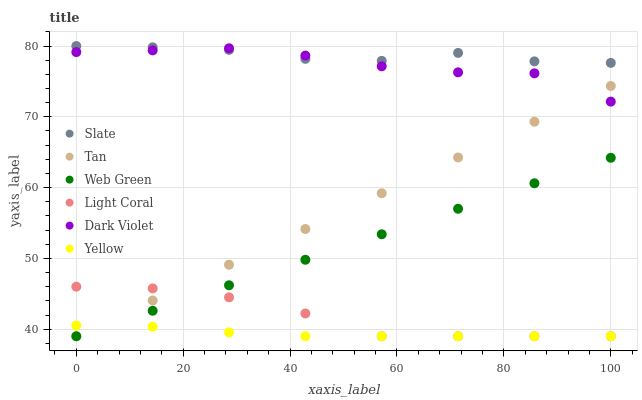Does Yellow have the minimum area under the curve?
Answer yes or no. Yes. Does Slate have the maximum area under the curve?
Answer yes or no. Yes. Does Slate have the minimum area under the curve?
Answer yes or no. No. Does Yellow have the maximum area under the curve?
Answer yes or no. No. Is Web Green the smoothest?
Answer yes or no. Yes. Is Dark Violet the roughest?
Answer yes or no. Yes. Is Slate the smoothest?
Answer yes or no. No. Is Slate the roughest?
Answer yes or no. No. Does Web Green have the lowest value?
Answer yes or no. Yes. Does Slate have the lowest value?
Answer yes or no. No. Does Slate have the highest value?
Answer yes or no. Yes. Does Yellow have the highest value?
Answer yes or no. No. Is Tan less than Slate?
Answer yes or no. Yes. Is Slate greater than Light Coral?
Answer yes or no. Yes. Does Light Coral intersect Tan?
Answer yes or no. Yes. Is Light Coral less than Tan?
Answer yes or no. No. Is Light Coral greater than Tan?
Answer yes or no. No. Does Tan intersect Slate?
Answer yes or no. No. 